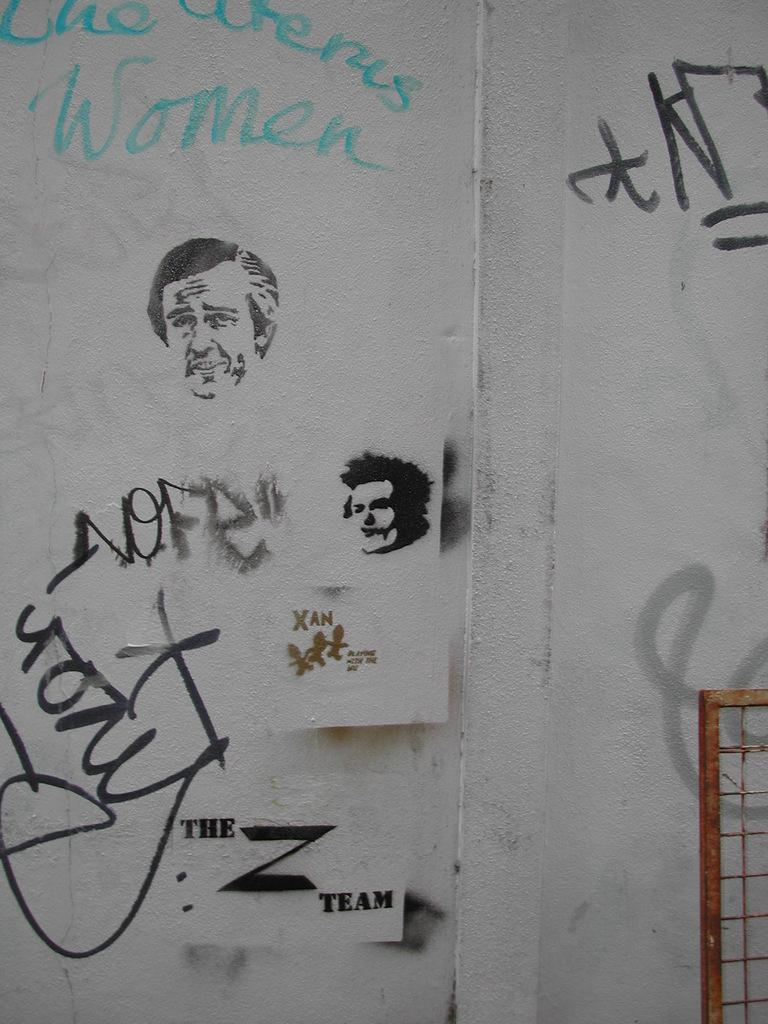What can be seen on the wall in the image? There are drawings and words on the wall in the image. Can you describe the fence in front of the wall? The fence in front of the wall is rusted. What type of wool is being spun by the tramp in the image? There is no tramp or wool present in the image; it only features drawings, words, and a rusted fence. 